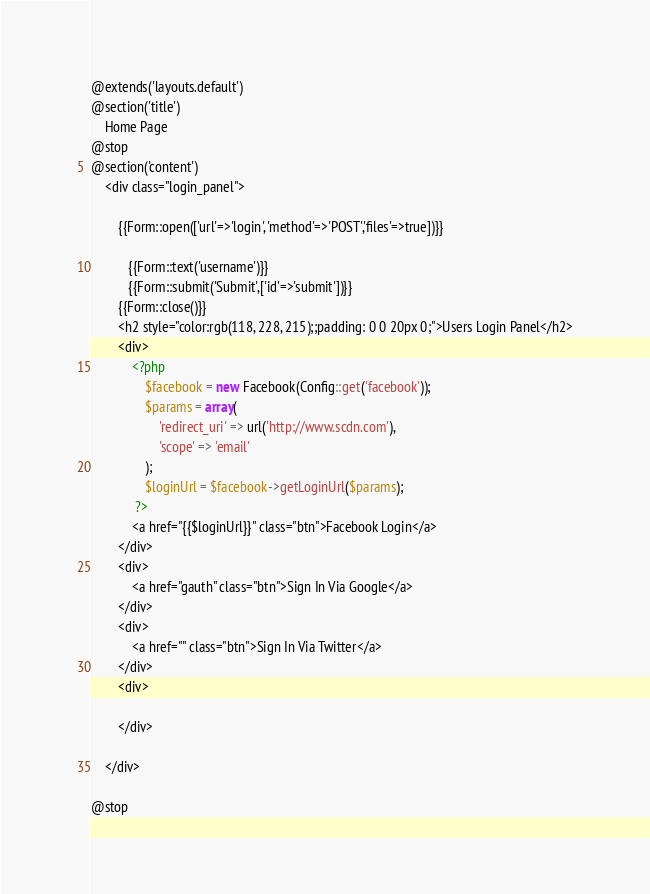Convert code to text. <code><loc_0><loc_0><loc_500><loc_500><_PHP_>@extends('layouts.default')
@section('title')
	Home Page
@stop
@section('content')
	<div class="login_panel">
		
		{{Form::open(['url'=>'login', 'method'=>'POST','files'=>true])}}

		   {{Form::text('username')}}
		   {{Form::submit('Submit',['id'=>'submit'])}}
		{{Form::close()}}
		<h2 style="color:rgb(118, 228, 215);;padding: 0 0 20px 0;">Users Login Panel</h2>
		<div>
			<?php 
				$facebook = new Facebook(Config::get('facebook'));
				$params = array(
			        'redirect_uri' => url('http://www.scdn.com'),
			        'scope' => 'email'
			    );
			    $loginUrl = $facebook->getLoginUrl($params);
			 ?>
	 		<a href="{{$loginUrl}}" class="btn">Facebook Login</a>
		</div>
		<div>
			<a href="gauth" class="btn">Sign In Via Google</a>
		</div>
		<div>
			<a href="" class="btn">Sign In Via Twitter</a>
		</div>
		<div>
			
		</div>

	</div>
	
@stop</code> 